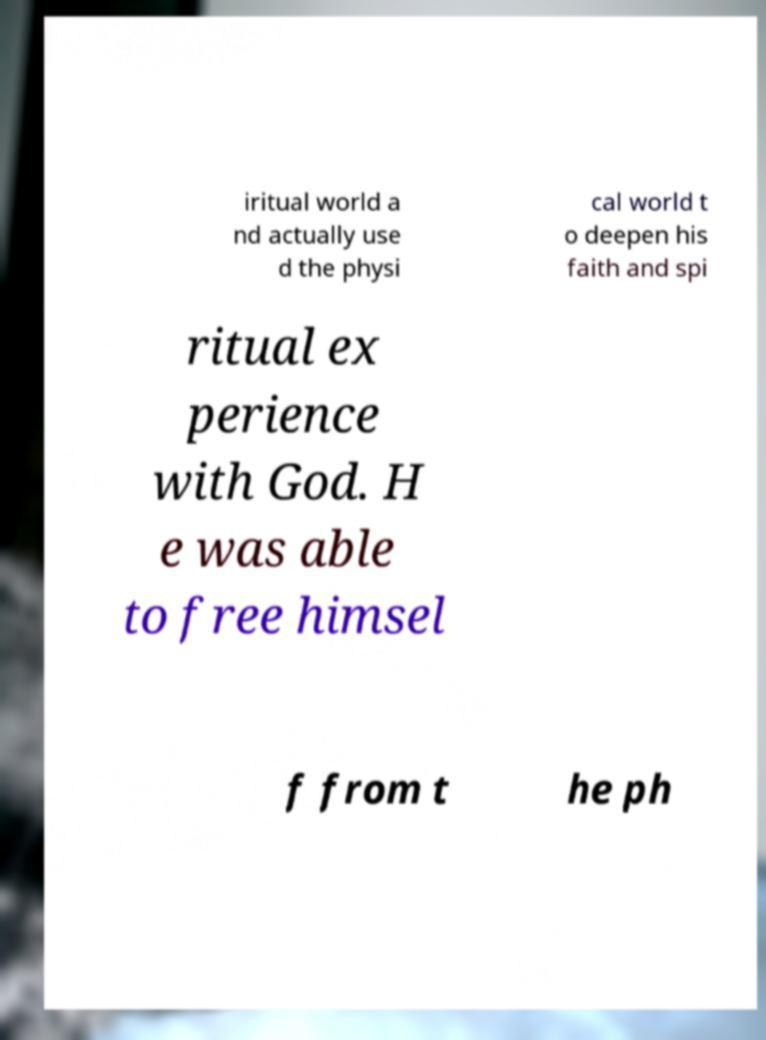I need the written content from this picture converted into text. Can you do that? iritual world a nd actually use d the physi cal world t o deepen his faith and spi ritual ex perience with God. H e was able to free himsel f from t he ph 